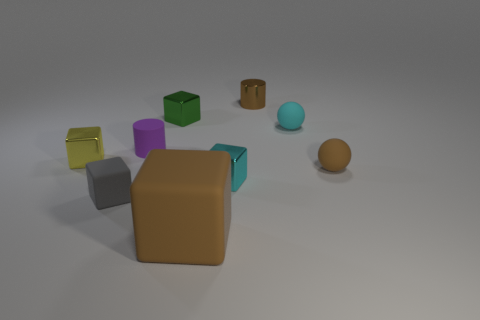Subtract all large brown matte blocks. How many blocks are left? 4 Subtract 2 blocks. How many blocks are left? 3 Subtract all brown blocks. How many blocks are left? 4 Subtract all yellow cubes. Subtract all cyan spheres. How many cubes are left? 4 Add 1 large green cubes. How many objects exist? 10 Subtract all blocks. How many objects are left? 4 Add 1 tiny purple cylinders. How many tiny purple cylinders are left? 2 Add 9 small brown cylinders. How many small brown cylinders exist? 10 Subtract 1 cyan blocks. How many objects are left? 8 Subtract all large red matte blocks. Subtract all tiny metallic cylinders. How many objects are left? 8 